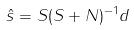<formula> <loc_0><loc_0><loc_500><loc_500>\hat { s } = S ( S + N ) ^ { - 1 } d</formula> 